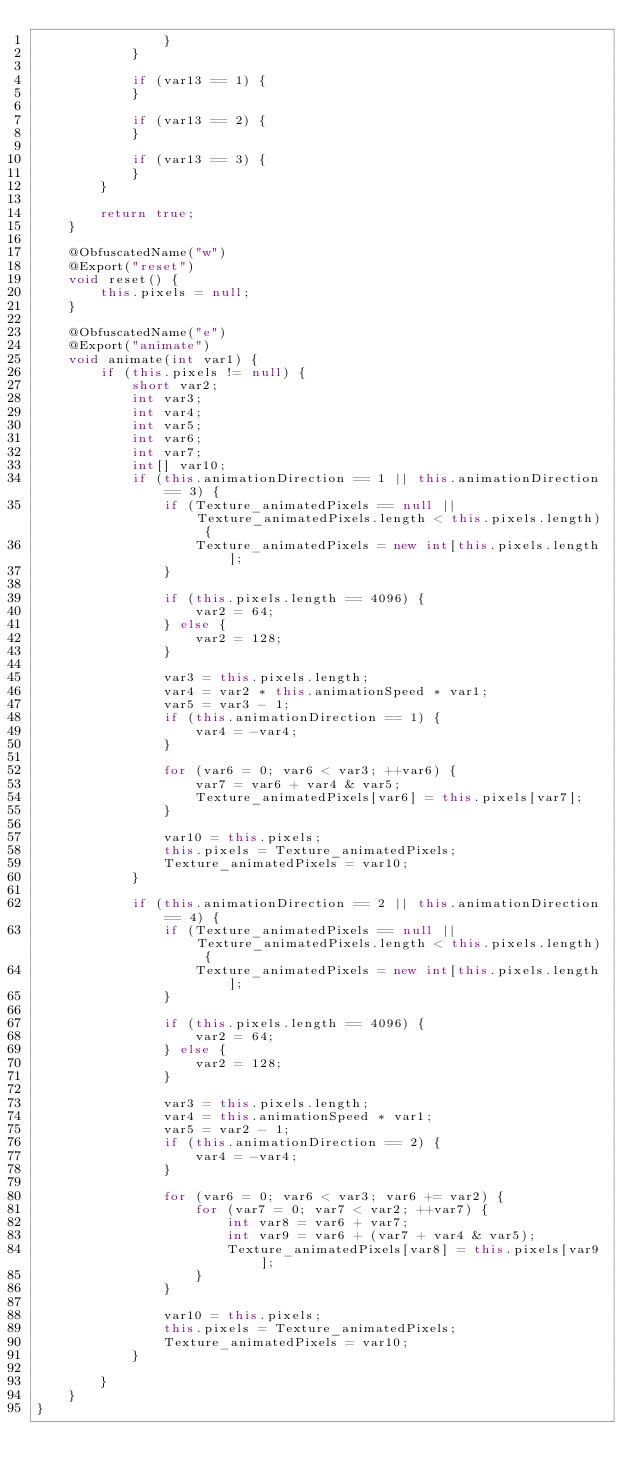<code> <loc_0><loc_0><loc_500><loc_500><_Java_>				}
			}

			if (var13 == 1) {
			}

			if (var13 == 2) {
			}

			if (var13 == 3) {
			}
		}

		return true;
	}

	@ObfuscatedName("w")
	@Export("reset")
	void reset() {
		this.pixels = null;
	}

	@ObfuscatedName("e")
	@Export("animate")
	void animate(int var1) {
		if (this.pixels != null) {
			short var2;
			int var3;
			int var4;
			int var5;
			int var6;
			int var7;
			int[] var10;
			if (this.animationDirection == 1 || this.animationDirection == 3) {
				if (Texture_animatedPixels == null || Texture_animatedPixels.length < this.pixels.length) {
					Texture_animatedPixels = new int[this.pixels.length];
				}

				if (this.pixels.length == 4096) {
					var2 = 64;
				} else {
					var2 = 128;
				}

				var3 = this.pixels.length;
				var4 = var2 * this.animationSpeed * var1;
				var5 = var3 - 1;
				if (this.animationDirection == 1) {
					var4 = -var4;
				}

				for (var6 = 0; var6 < var3; ++var6) {
					var7 = var6 + var4 & var5;
					Texture_animatedPixels[var6] = this.pixels[var7];
				}

				var10 = this.pixels;
				this.pixels = Texture_animatedPixels;
				Texture_animatedPixels = var10;
			}

			if (this.animationDirection == 2 || this.animationDirection == 4) {
				if (Texture_animatedPixels == null || Texture_animatedPixels.length < this.pixels.length) {
					Texture_animatedPixels = new int[this.pixels.length];
				}

				if (this.pixels.length == 4096) {
					var2 = 64;
				} else {
					var2 = 128;
				}

				var3 = this.pixels.length;
				var4 = this.animationSpeed * var1;
				var5 = var2 - 1;
				if (this.animationDirection == 2) {
					var4 = -var4;
				}

				for (var6 = 0; var6 < var3; var6 += var2) {
					for (var7 = 0; var7 < var2; ++var7) {
						int var8 = var6 + var7;
						int var9 = var6 + (var7 + var4 & var5);
						Texture_animatedPixels[var8] = this.pixels[var9];
					}
				}

				var10 = this.pixels;
				this.pixels = Texture_animatedPixels;
				Texture_animatedPixels = var10;
			}

		}
	}
}
</code> 